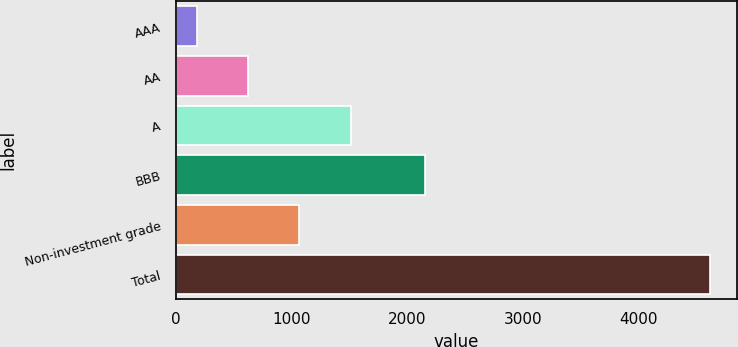Convert chart. <chart><loc_0><loc_0><loc_500><loc_500><bar_chart><fcel>AAA<fcel>AA<fcel>A<fcel>BBB<fcel>Non-investment grade<fcel>Total<nl><fcel>183<fcel>626.1<fcel>1512.3<fcel>2150<fcel>1069.2<fcel>4614<nl></chart> 